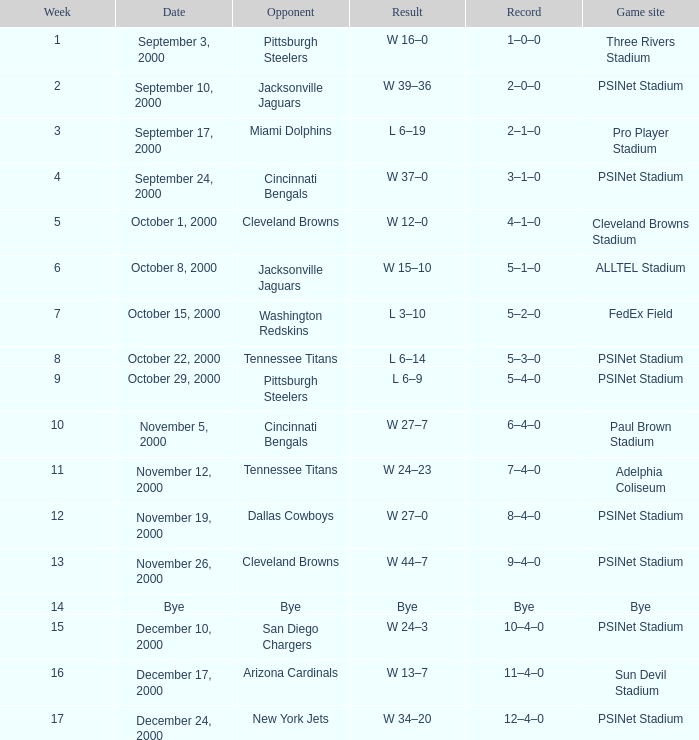What is the standing after the 16th week? 12–4–0. 